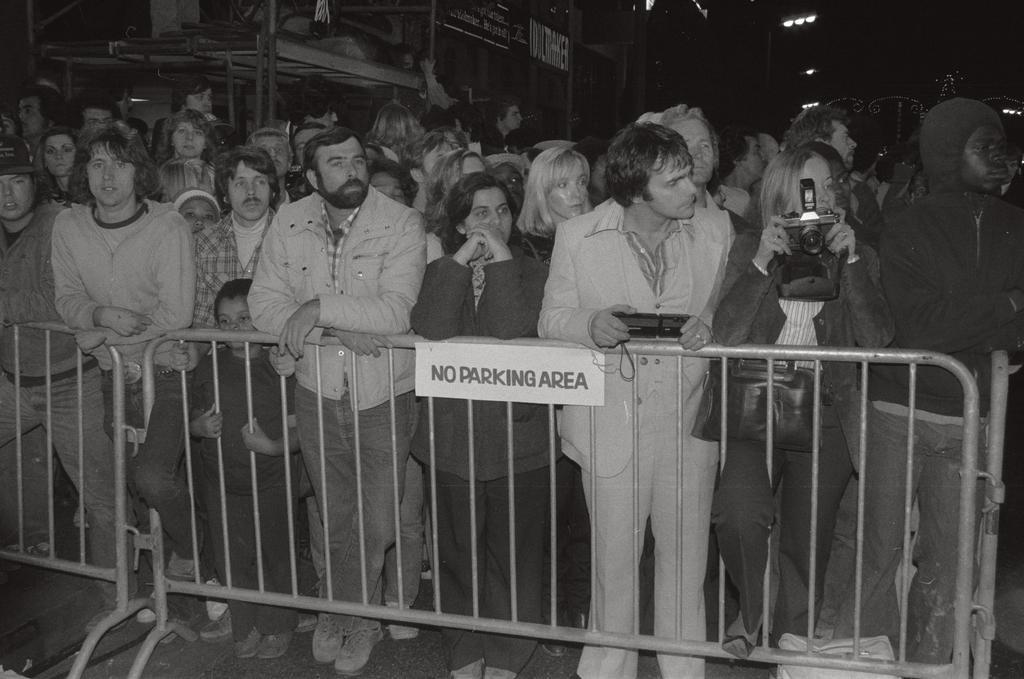Can you describe this image briefly? In this image we can see black and white picture of a group of persons standing on the floor. One woman is wearing bag and holding a camera in her hand. One person is holding an object in his hands. In the foreground of the image we can see a board with some text on a barricade. In the background, we can see a group of poles and some lights. 